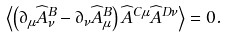<formula> <loc_0><loc_0><loc_500><loc_500>\left \langle \left ( \partial _ { \mu } \widehat { A } ^ { B } _ { \nu } - \partial _ { \nu } \widehat { A } ^ { B } _ { \mu } \right ) \widehat { A } ^ { C \mu } \widehat { A } ^ { D \nu } \right \rangle = 0 .</formula> 